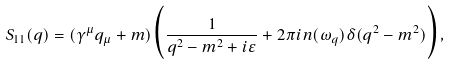<formula> <loc_0><loc_0><loc_500><loc_500>S _ { 1 1 } ( q ) = ( \gamma ^ { \mu } q _ { \mu } + m ) \Big { ( } \frac { 1 } { q ^ { 2 } - m ^ { 2 } + i \varepsilon } + 2 \pi i n ( \omega _ { q } ) \delta ( q ^ { 2 } - m ^ { 2 } ) \Big { ) } , \\</formula> 